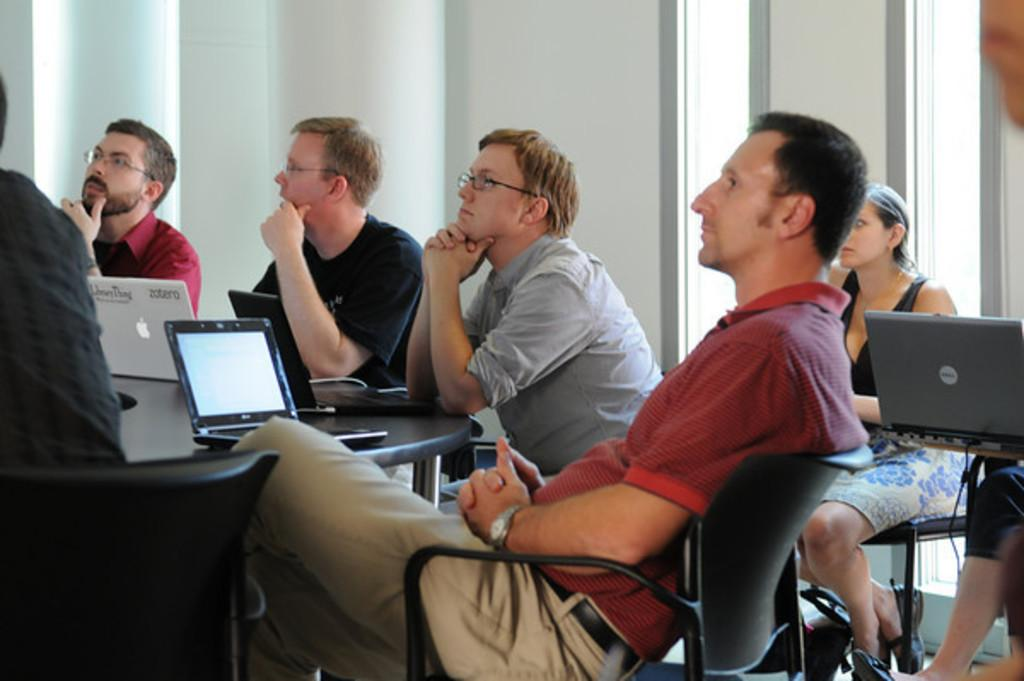What are the men in the image doing? The men in the image are sitting on chairs. What objects are on the table in the image? There are laptops on a table in the image. Can you describe the woman in the image? There is a woman in the image, but no specific details about her are provided. Where is the laptop located on the right side of the image? There is a laptop on the right side of the image. Can you see any ants crawling on the laptops in the image? There are no ants visible in the image. What type of needle is being used by the woman in the image? There is no woman using a needle in the image. Is there a kettle visible in the image? There is no kettle present in the image. 